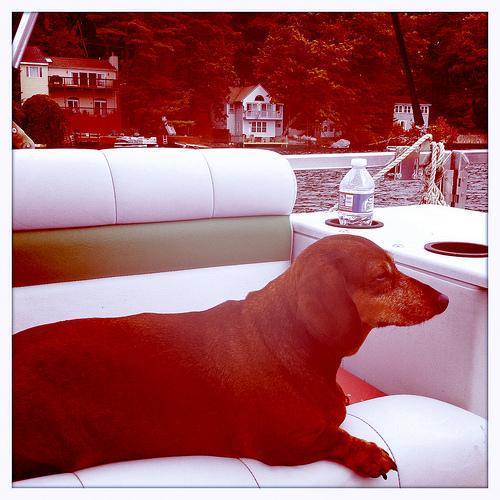How many houses are in the background?
Give a very brief answer. 3. How many cup holders are there?
Give a very brief answer. 2. 